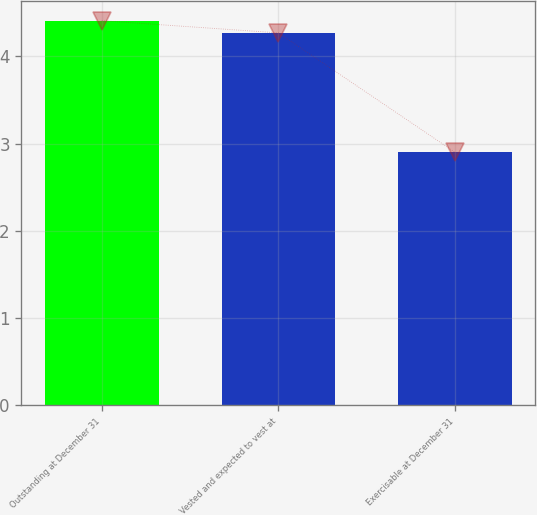Convert chart to OTSL. <chart><loc_0><loc_0><loc_500><loc_500><bar_chart><fcel>Outstanding at December 31<fcel>Vested and expected to vest at<fcel>Exercisable at December 31<nl><fcel>4.41<fcel>4.27<fcel>2.9<nl></chart> 